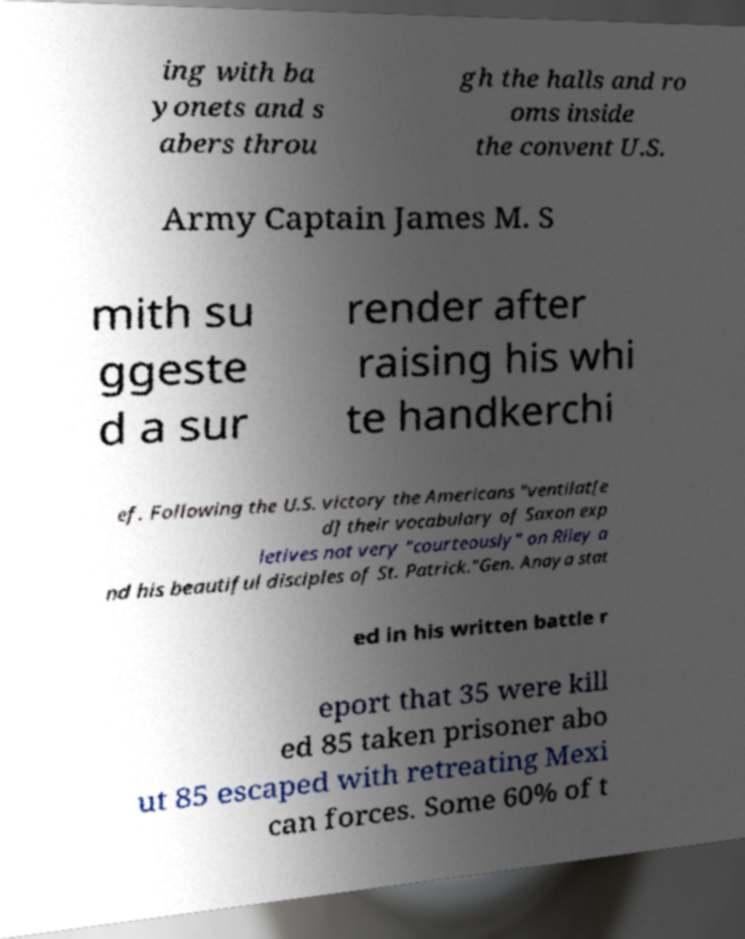Can you accurately transcribe the text from the provided image for me? ing with ba yonets and s abers throu gh the halls and ro oms inside the convent U.S. Army Captain James M. S mith su ggeste d a sur render after raising his whi te handkerchi ef. Following the U.S. victory the Americans "ventilat[e d] their vocabulary of Saxon exp letives not very "courteously" on Riley a nd his beautiful disciples of St. Patrick."Gen. Anaya stat ed in his written battle r eport that 35 were kill ed 85 taken prisoner abo ut 85 escaped with retreating Mexi can forces. Some 60% of t 